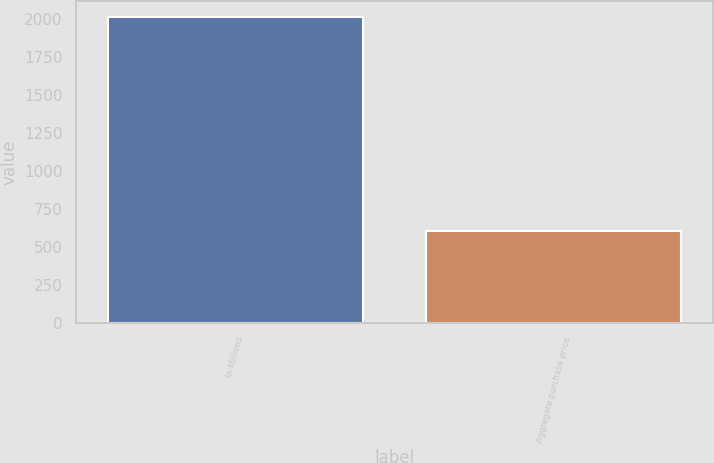<chart> <loc_0><loc_0><loc_500><loc_500><bar_chart><fcel>In Millions<fcel>Aggregate purchase price<nl><fcel>2018<fcel>601.6<nl></chart> 